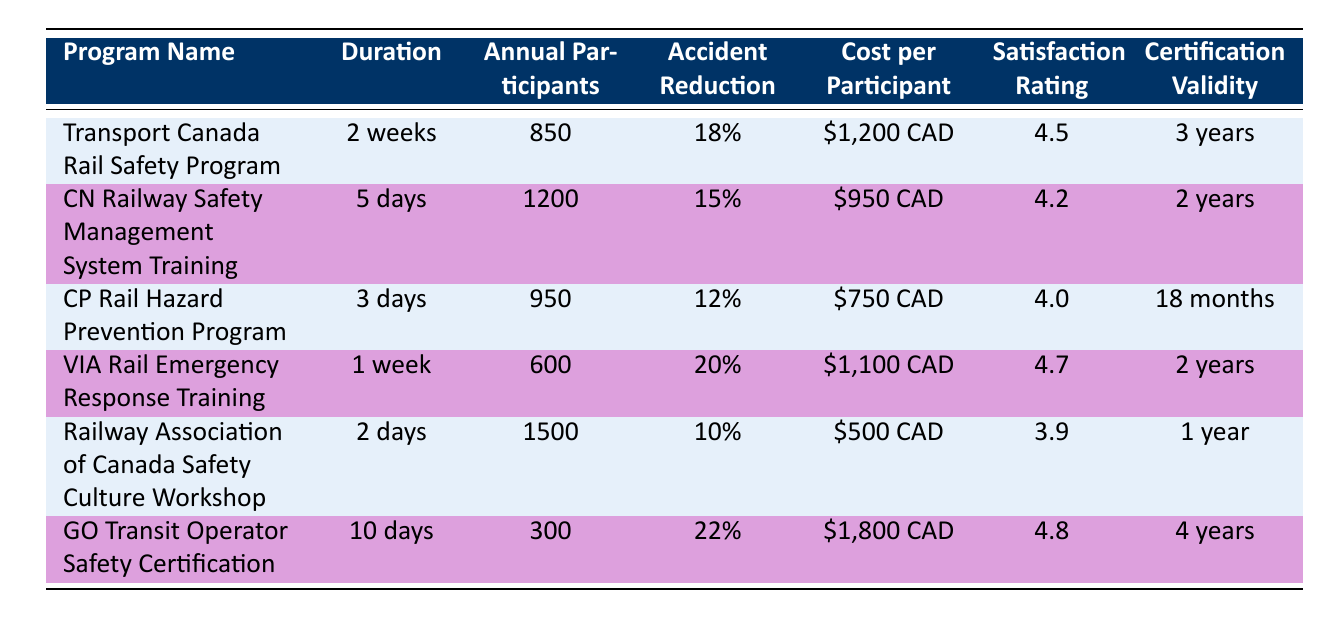What is the duration of the CN Railway Safety Management System Training? The duration for the CN Railway Safety Management System Training is listed directly in the table as 5 days.
Answer: 5 days Which program has the highest annual participants? The program with the highest annual participants is the Railway Association of Canada Safety Culture Workshop, with 1500 participants.
Answer: Railway Association of Canada Safety Culture Workshop Is the accident reduction rate for the VIA Rail Emergency Response Training higher than that of the CP Rail Hazard Prevention Program? The accident reduction rate for VIA Rail Emergency Response Training is 20%, while CP Rail Hazard Prevention Program has 12%. Since 20% is greater than 12%, the answer is yes.
Answer: Yes What is the average cost per participant for all these programs? First, we sum the costs per participant for each program: $1,200 + $950 + $750 + $1,100 + $500 + $1,800 = $6,300. Then we divide by the number of programs (6), which gives us $6,300 / 6 = $1,050.
Answer: $1,050 Which program has the longest certification validity? The program with the longest certification validity is the GO Transit Operator Safety Certification, which is valid for 4 years.
Answer: GO Transit Operator Safety Certification Are there more participants in the Transport Canada Rail Safety Program than in the VIA Rail Emergency Response Training? The Transport Canada Rail Safety Program has 850 participants, whereas VIA Rail Emergency Response Training has 600 participants. Since 850 is greater than 600, the answer is yes.
Answer: Yes What is the satisfaction rating difference between the GO Transit Operator Safety Certification and the Railway Association of Canada Safety Culture Workshop? The satisfaction rating for GO Transit Operator Safety Certification is 4.8 and for Railway Association of Canada Safety Culture Workshop is 3.9. The difference is 4.8 - 3.9 = 0.9.
Answer: 0.9 Which program has the shortest duration and what is that duration? The program with the shortest duration is the CP Rail Hazard Prevention Program, which lasts for 3 days.
Answer: CP Rail Hazard Prevention Program, 3 days If we consider only the programs with a satisfaction rating higher than 4.5, which programs qualify and what is their accident reduction rate? The programs with a satisfaction rating higher than 4.5 are VIA Rail Emergency Response Training (4.7 with a 20% accident reduction rate) and GO Transit Operator Safety Certification (4.8 with a 22% accident reduction rate).
Answer: VIA Rail Emergency Response Training (20%), GO Transit Operator Safety Certification (22%) 